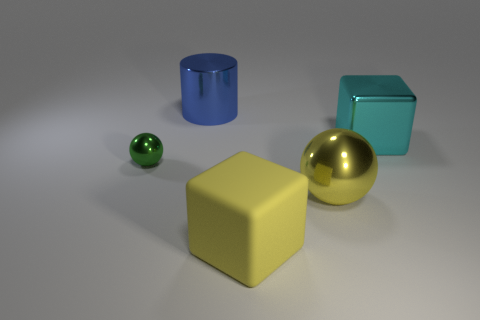Add 2 big yellow metal objects. How many objects exist? 7 Subtract all green spheres. How many spheres are left? 1 Subtract all spheres. How many objects are left? 3 Subtract all yellow cubes. How many green balls are left? 1 Subtract all cyan balls. Subtract all green blocks. How many balls are left? 2 Subtract all large cylinders. Subtract all blue metallic cylinders. How many objects are left? 3 Add 1 green shiny things. How many green shiny things are left? 2 Add 4 tiny purple cylinders. How many tiny purple cylinders exist? 4 Subtract 0 gray cylinders. How many objects are left? 5 Subtract 1 cylinders. How many cylinders are left? 0 